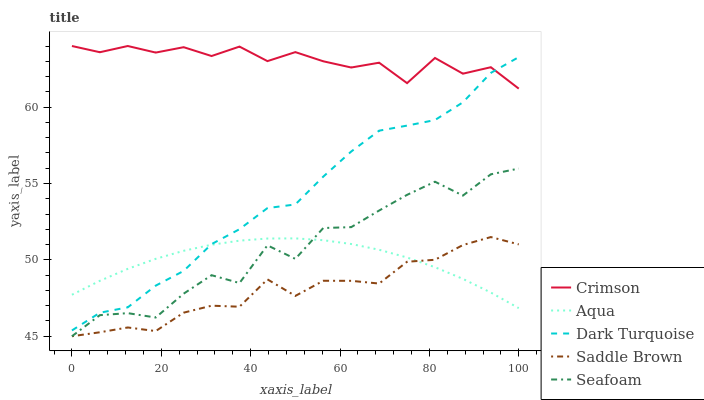Does Dark Turquoise have the minimum area under the curve?
Answer yes or no. No. Does Dark Turquoise have the maximum area under the curve?
Answer yes or no. No. Is Dark Turquoise the smoothest?
Answer yes or no. No. Is Dark Turquoise the roughest?
Answer yes or no. No. Does Dark Turquoise have the lowest value?
Answer yes or no. No. Does Dark Turquoise have the highest value?
Answer yes or no. No. Is Saddle Brown less than Dark Turquoise?
Answer yes or no. Yes. Is Crimson greater than Aqua?
Answer yes or no. Yes. Does Saddle Brown intersect Dark Turquoise?
Answer yes or no. No. 